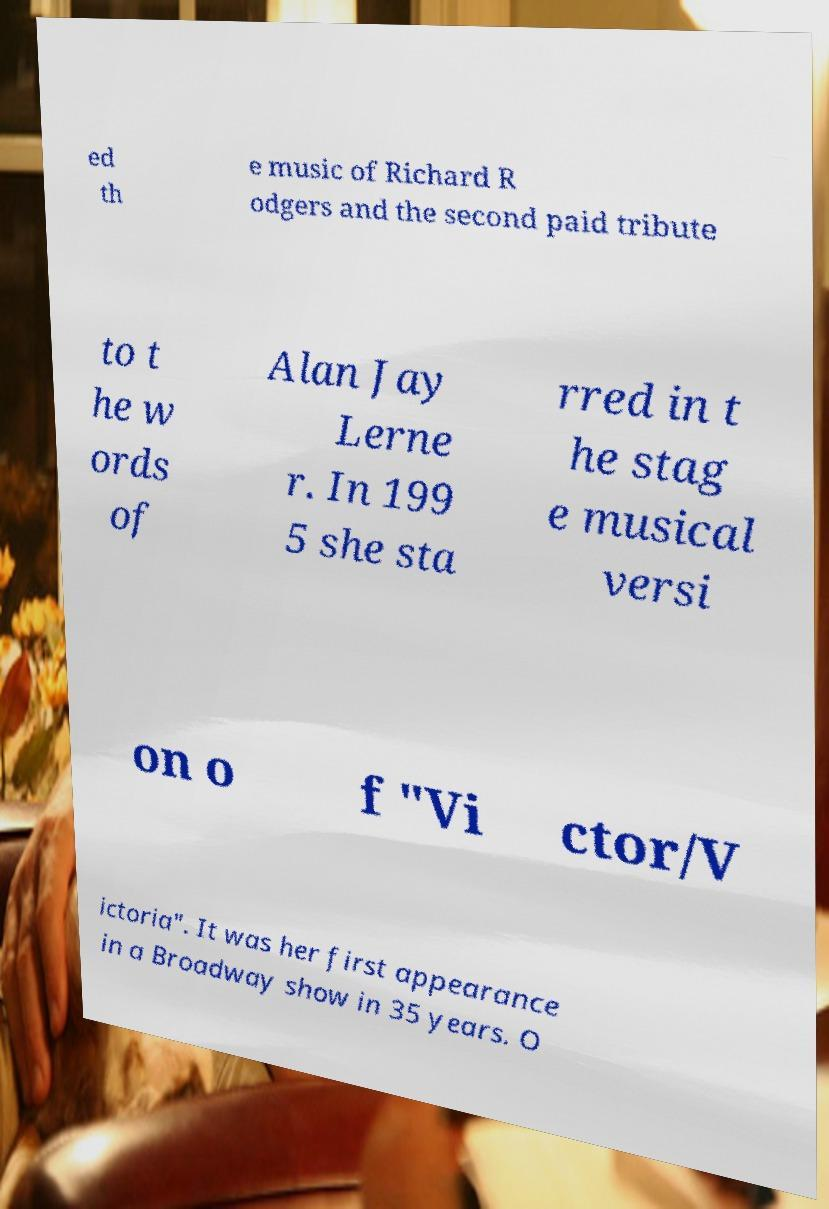Could you extract and type out the text from this image? ed th e music of Richard R odgers and the second paid tribute to t he w ords of Alan Jay Lerne r. In 199 5 she sta rred in t he stag e musical versi on o f "Vi ctor/V ictoria". It was her first appearance in a Broadway show in 35 years. O 